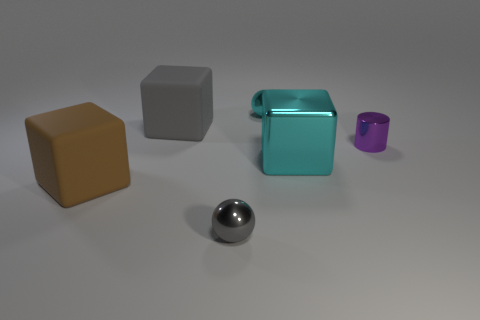Can you describe the lighting and shadows present in the image? The lighting in the image is diffuse and soft, coming from above and creating gentle shadows below each object. The shadows are relatively soft and not very pronounced, indicating that the light source is neither very close nor overly intense. 